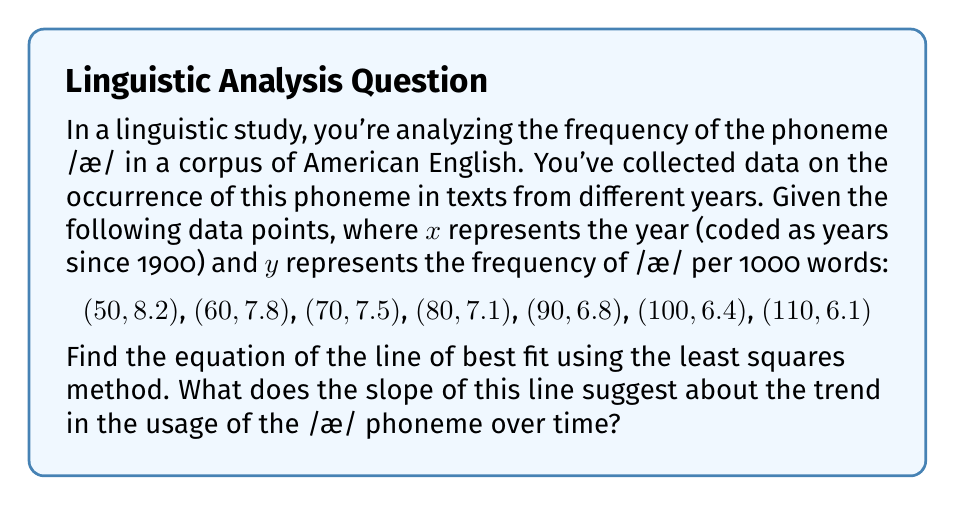Show me your answer to this math problem. To find the line of best fit using the least squares method, we need to calculate the slope (m) and y-intercept (b) of the equation $y = mx + b$.

Step 1: Calculate the means of x and y
$\bar{x} = \frac{50 + 60 + 70 + 80 + 90 + 100 + 110}{7} = 80$
$\bar{y} = \frac{8.2 + 7.8 + 7.5 + 7.1 + 6.8 + 6.4 + 6.1}{7} = 7.1$

Step 2: Calculate the slope (m)
$$m = \frac{\sum(x_i - \bar{x})(y_i - \bar{y})}{\sum(x_i - \bar{x})^2}$$

Calculate the numerator and denominator:
$\sum(x_i - \bar{x})(y_i - \bar{y}) = -210$
$\sum(x_i - \bar{x})^2 = 4900$

$m = \frac{-210}{4900} = -0.0429$

Step 3: Calculate the y-intercept (b)
$b = \bar{y} - m\bar{x} = 7.1 - (-0.0429 * 80) = 10.5286$

Step 4: Write the equation of the line
$y = -0.0429x + 10.5286$

Interpretation: The negative slope (-0.0429) indicates that the frequency of the /æ/ phoneme is decreasing over time. Specifically, for each year that passes, the frequency of /æ/ decreases by approximately 0.0429 occurrences per 1000 words.
Answer: $y = -0.0429x + 10.5286$; The negative slope suggests a decreasing trend in the usage of the /æ/ phoneme over time. 